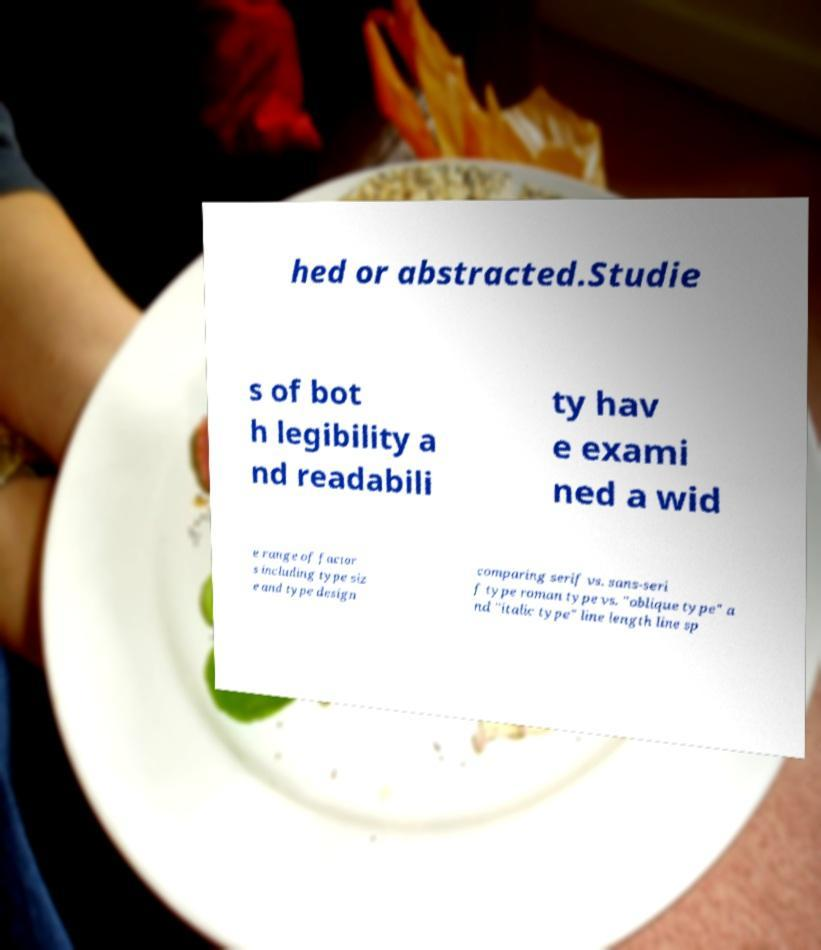I need the written content from this picture converted into text. Can you do that? hed or abstracted.Studie s of bot h legibility a nd readabili ty hav e exami ned a wid e range of factor s including type siz e and type design comparing serif vs. sans-seri f type roman type vs. "oblique type" a nd "italic type" line length line sp 